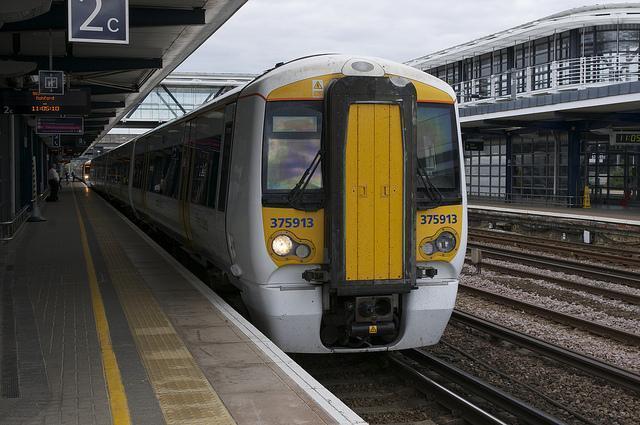How many of the people walk right?
Give a very brief answer. 0. 